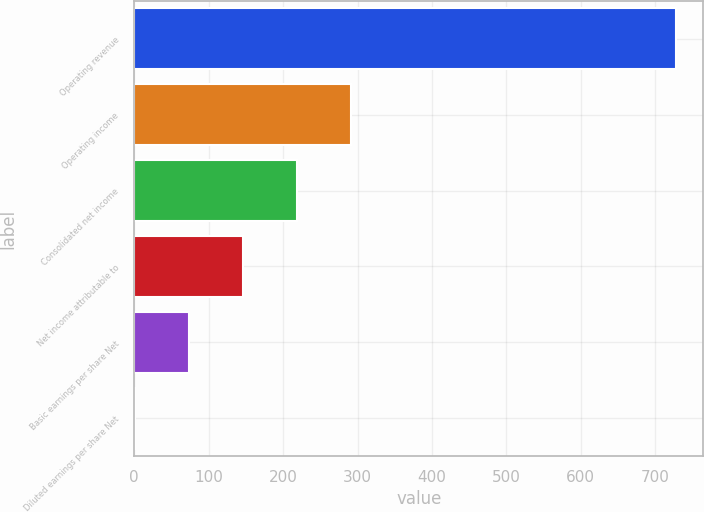<chart> <loc_0><loc_0><loc_500><loc_500><bar_chart><fcel>Operating revenue<fcel>Operating income<fcel>Consolidated net income<fcel>Net income attributable to<fcel>Basic earnings per share Net<fcel>Diluted earnings per share Net<nl><fcel>728.3<fcel>291.81<fcel>219.07<fcel>146.33<fcel>73.59<fcel>0.85<nl></chart> 